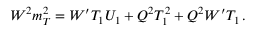Convert formula to latex. <formula><loc_0><loc_0><loc_500><loc_500>W ^ { 2 } m _ { T } ^ { 2 } = W ^ { \prime } T _ { 1 } U _ { 1 } + Q ^ { 2 } T _ { 1 } ^ { 2 } + Q ^ { 2 } W ^ { \prime } T _ { 1 } \, .</formula> 